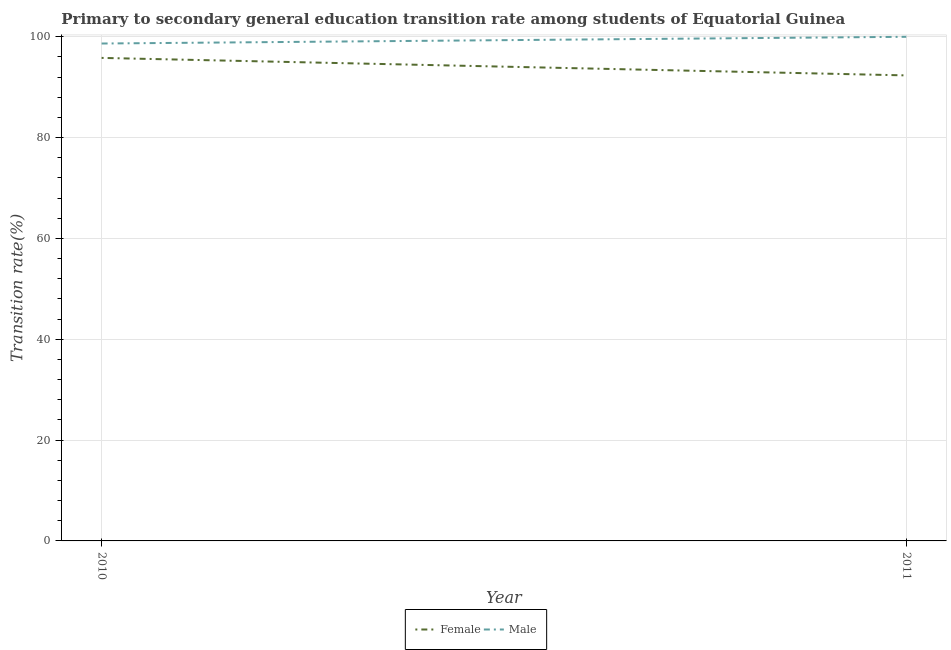How many different coloured lines are there?
Your response must be concise. 2. Does the line corresponding to transition rate among male students intersect with the line corresponding to transition rate among female students?
Provide a short and direct response. No. What is the transition rate among male students in 2011?
Your answer should be very brief. 100. Across all years, what is the minimum transition rate among male students?
Make the answer very short. 98.67. In which year was the transition rate among male students maximum?
Provide a succinct answer. 2011. In which year was the transition rate among male students minimum?
Your answer should be very brief. 2010. What is the total transition rate among male students in the graph?
Your answer should be compact. 198.67. What is the difference between the transition rate among male students in 2010 and that in 2011?
Offer a very short reply. -1.33. What is the difference between the transition rate among male students in 2011 and the transition rate among female students in 2010?
Offer a very short reply. 4.19. What is the average transition rate among female students per year?
Your answer should be compact. 94.08. In the year 2011, what is the difference between the transition rate among male students and transition rate among female students?
Your answer should be compact. 7.66. In how many years, is the transition rate among female students greater than 52 %?
Your answer should be very brief. 2. What is the ratio of the transition rate among male students in 2010 to that in 2011?
Your response must be concise. 0.99. Is the transition rate among male students in 2010 less than that in 2011?
Your response must be concise. Yes. In how many years, is the transition rate among male students greater than the average transition rate among male students taken over all years?
Keep it short and to the point. 1. Does the transition rate among female students monotonically increase over the years?
Give a very brief answer. No. Is the transition rate among female students strictly greater than the transition rate among male students over the years?
Make the answer very short. No. Is the transition rate among female students strictly less than the transition rate among male students over the years?
Provide a succinct answer. Yes. How many years are there in the graph?
Offer a terse response. 2. Does the graph contain any zero values?
Your answer should be compact. No. How many legend labels are there?
Give a very brief answer. 2. How are the legend labels stacked?
Your answer should be very brief. Horizontal. What is the title of the graph?
Keep it short and to the point. Primary to secondary general education transition rate among students of Equatorial Guinea. Does "Goods and services" appear as one of the legend labels in the graph?
Offer a very short reply. No. What is the label or title of the X-axis?
Provide a succinct answer. Year. What is the label or title of the Y-axis?
Provide a succinct answer. Transition rate(%). What is the Transition rate(%) in Female in 2010?
Your answer should be very brief. 95.81. What is the Transition rate(%) of Male in 2010?
Offer a very short reply. 98.67. What is the Transition rate(%) of Female in 2011?
Make the answer very short. 92.34. Across all years, what is the maximum Transition rate(%) in Female?
Ensure brevity in your answer.  95.81. Across all years, what is the minimum Transition rate(%) of Female?
Your response must be concise. 92.34. Across all years, what is the minimum Transition rate(%) of Male?
Make the answer very short. 98.67. What is the total Transition rate(%) of Female in the graph?
Provide a short and direct response. 188.16. What is the total Transition rate(%) of Male in the graph?
Your answer should be very brief. 198.67. What is the difference between the Transition rate(%) of Female in 2010 and that in 2011?
Provide a succinct answer. 3.47. What is the difference between the Transition rate(%) of Male in 2010 and that in 2011?
Offer a terse response. -1.33. What is the difference between the Transition rate(%) of Female in 2010 and the Transition rate(%) of Male in 2011?
Your answer should be very brief. -4.19. What is the average Transition rate(%) in Female per year?
Your response must be concise. 94.08. What is the average Transition rate(%) of Male per year?
Your response must be concise. 99.33. In the year 2010, what is the difference between the Transition rate(%) of Female and Transition rate(%) of Male?
Offer a terse response. -2.85. In the year 2011, what is the difference between the Transition rate(%) in Female and Transition rate(%) in Male?
Give a very brief answer. -7.66. What is the ratio of the Transition rate(%) of Female in 2010 to that in 2011?
Provide a short and direct response. 1.04. What is the ratio of the Transition rate(%) in Male in 2010 to that in 2011?
Provide a short and direct response. 0.99. What is the difference between the highest and the second highest Transition rate(%) in Female?
Ensure brevity in your answer.  3.47. What is the difference between the highest and the second highest Transition rate(%) in Male?
Provide a succinct answer. 1.33. What is the difference between the highest and the lowest Transition rate(%) in Female?
Provide a succinct answer. 3.47. What is the difference between the highest and the lowest Transition rate(%) of Male?
Offer a very short reply. 1.33. 